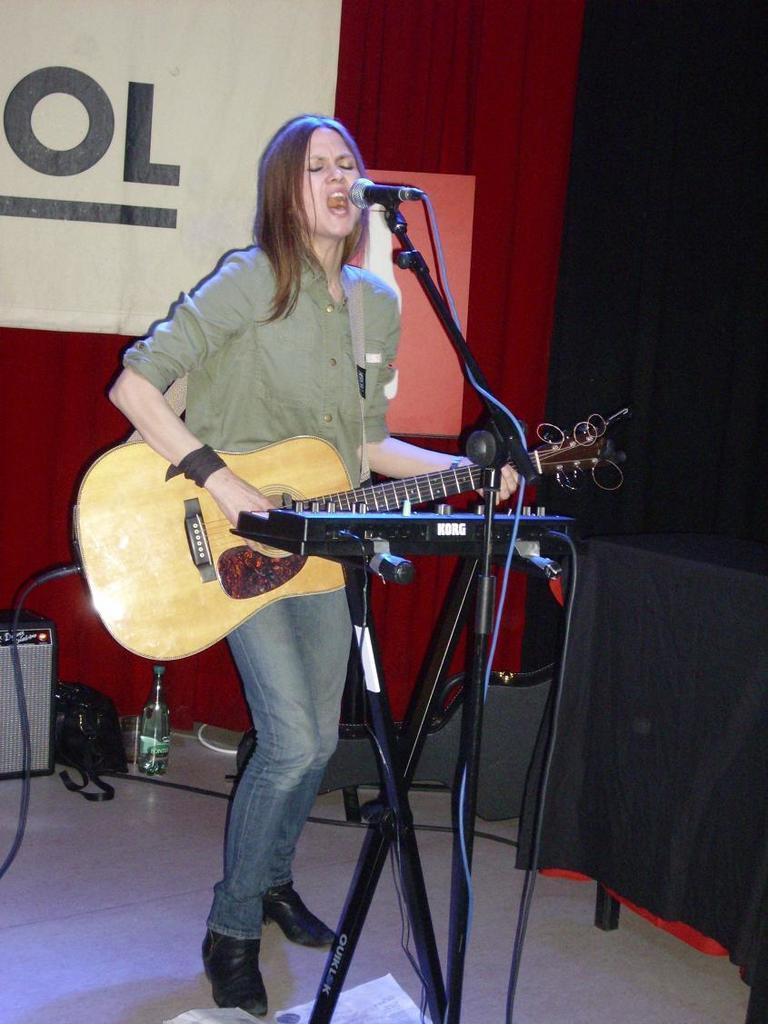What is the woman in the image doing? The woman is playing the guitar and singing on a microphone. What instrument is the woman holding in the image? The woman is holding a guitar in the image. What can be seen in the background of the image? There is a wall, speakers, a bag, and a bottle in the background of the image. What type of cloth is being used to cover the dinner table in the image? There is no dinner table or cloth present in the image. 